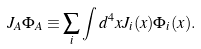Convert formula to latex. <formula><loc_0><loc_0><loc_500><loc_500>J _ { A } \Phi _ { A } \equiv \sum _ { i } \int d ^ { 4 } x J _ { i } ( x ) \Phi _ { i } ( x ) .</formula> 